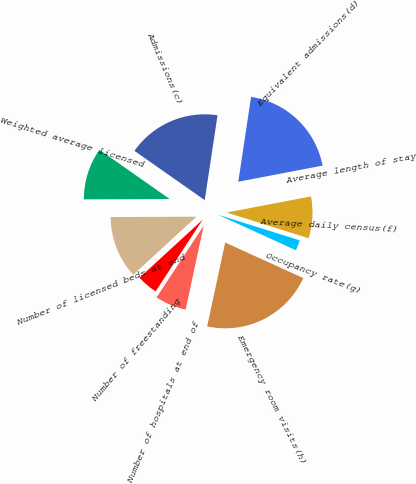<chart> <loc_0><loc_0><loc_500><loc_500><pie_chart><fcel>Number of hospitals at end of<fcel>Number of freestanding<fcel>Number of licensed beds at end<fcel>Weighted average licensed<fcel>Admissions(c)<fcel>Equivalent admissions(d)<fcel>Average length of stay<fcel>Average daily census(f)<fcel>Occupancy rate(g)<fcel>Emergency room visits(h)<nl><fcel>5.88%<fcel>3.92%<fcel>11.76%<fcel>9.8%<fcel>17.65%<fcel>19.61%<fcel>0.0%<fcel>7.84%<fcel>1.96%<fcel>21.57%<nl></chart> 